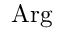<formula> <loc_0><loc_0><loc_500><loc_500>A r g</formula> 